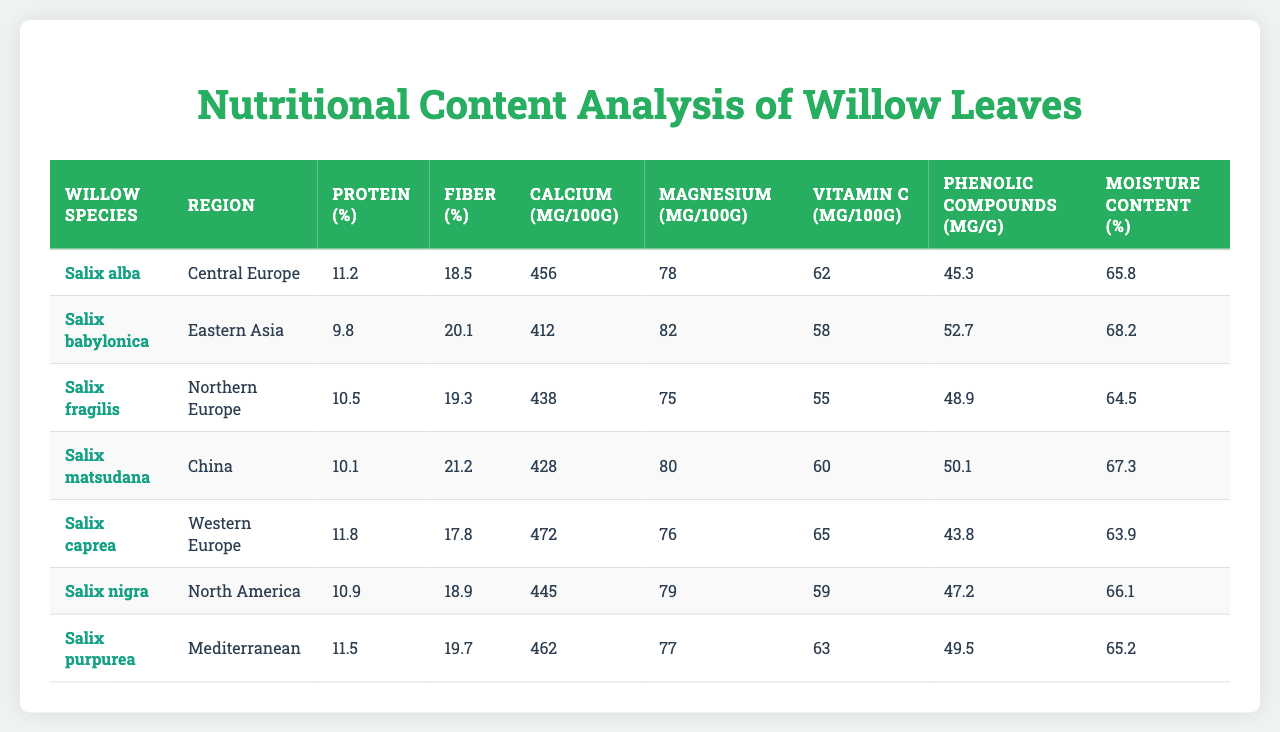What is the protein content of Salix nigra? From the table, the protein content for Salix nigra is listed as 10.9%.
Answer: 10.9% Which willow species has the highest calcium content? By examining the calcium content in the table, Salix caprea has the highest calcium value at 472 mg/100g.
Answer: Salix caprea What is the average moisture content of the willow leaves in the table? Adding the moisture content values (65.8 + 68.2 + 64.5 + 67.3 + 63.9 + 66.1 + 65.2 = 421.0) and dividing by the number of species (7) gives an average of approximately 60.14%.
Answer: 65.14% Is it true that Salix alba has a higher protein percentage than Salix purpurea? Salix alba has a protein content of 11.2%, while Salix purpurea has 11.5%. Therefore, the statement is false.
Answer: False Which region has the lowest fiber percentage in willow leaves? Reviewing the fiber percentages, Eastern Asia's Salix babylonica has the lowest fiber content at 20.1%.
Answer: Eastern Asia What is the difference in vitamin C content between Salix matsudana and Salix nigra? Salix matsudana has 60 mg/100g and Salix nigra has 59 mg/100g. The difference is 60 - 59 = 1 mg/100g.
Answer: 1 mg/100g Which species has the highest and lowest phenolic compounds content? Salix babylonica has the highest phenolic content at 52.7 mg/g, while Salix caprea has the lowest at 43.8 mg/g.
Answer: Highest: Salix babylonica; Lowest: Salix caprea If you combine the protein content of Salix alba and Salix fragilis, what will be the total protein percentage? Salix alba has 11.2%, and Salix fragilis has 10.5%. Adding them gives 11.2 + 10.5 = 21.7%.
Answer: 21.7% What is the moisture content of Salix matsudana compared to Salix babylonica? Salix matsudana has a moisture content of 67.3% while Salix babylonica has 68.2%. Salix babylonica has a higher moisture content.
Answer: Salix babylonica is higher How many species have a magnesium content greater than 79 mg/100g? Reviewing the magnesium content, only Salix alba (78), Salix babylonica (82), Salix matsudana (80), and Salix purpurea (77) are over 79 mg/100g. This means there are 3 species with greater magnesium.
Answer: 2 species 